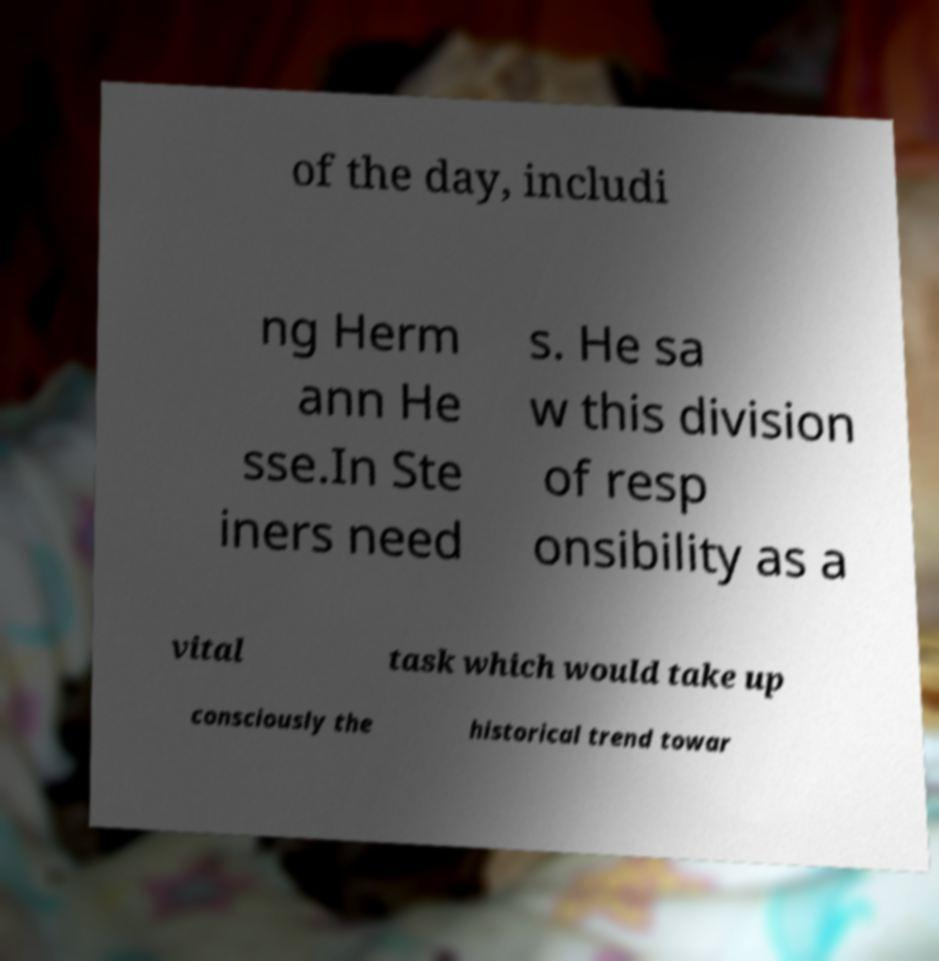Please read and relay the text visible in this image. What does it say? of the day, includi ng Herm ann He sse.In Ste iners need s. He sa w this division of resp onsibility as a vital task which would take up consciously the historical trend towar 